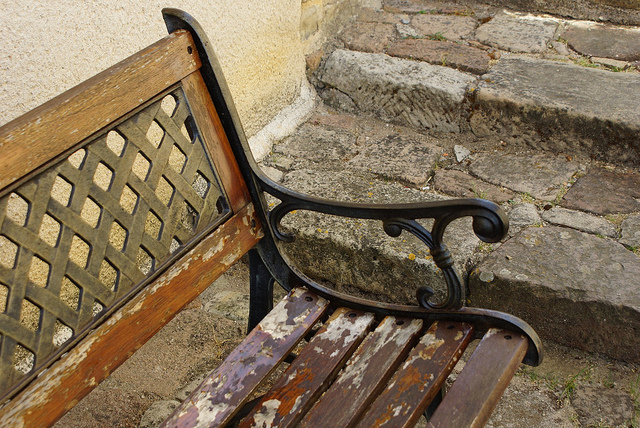How many steps are visible? There are two stone steps visible in the image, leading up from the area where the bench is placed. 